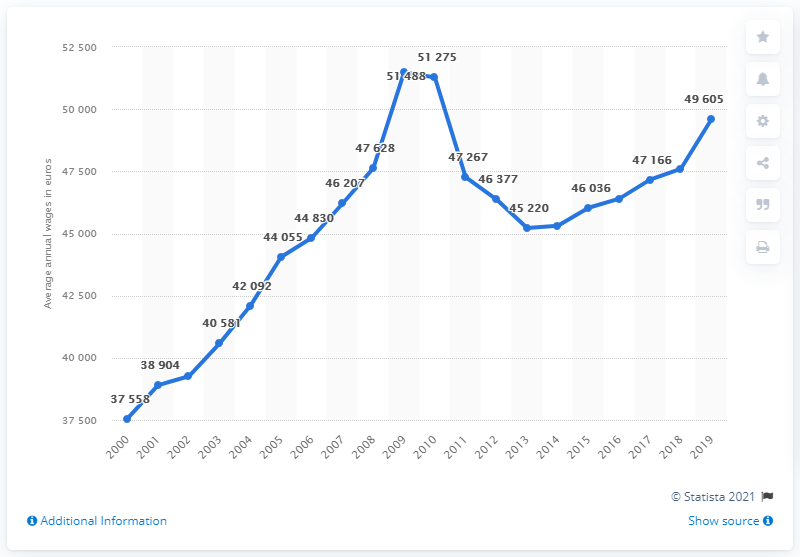Point out several critical features in this image. In 2008, the average annual wage in Ireland was 51,275 Euros. The average annual wage in Ireland in 2019 was 49,605. According to data from 2000 to 2019, the average annual wage in Ireland was approximately 51,275. 